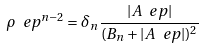Convert formula to latex. <formula><loc_0><loc_0><loc_500><loc_500>\rho _ { \ } e p ^ { n - 2 } = \delta _ { n } \frac { | A _ { \ } e p | } { ( B _ { n } + | A _ { \ } e p | ) ^ { 2 } }</formula> 